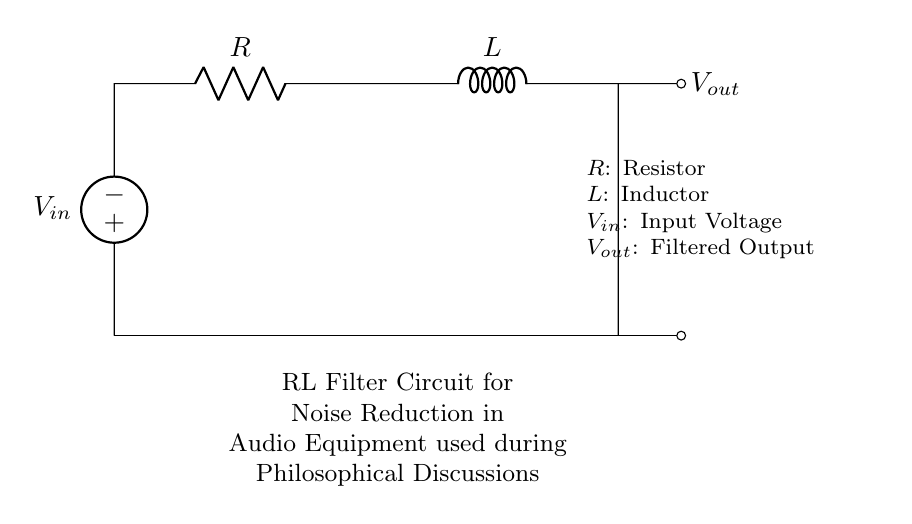What is the type of this circuit? The circuit consists of a resistor and an inductor connected in series, which classifies it as an RL filter circuit.
Answer: RL filter What is the role of the resistor in this circuit? The resistor is primarily used to limit the current flowing through the circuit and helps to set the cutoff frequency along with the inductor.
Answer: Current limiter What is the purpose of the inductor in this RL circuit? The inductor stores energy in a magnetic field when current passes through it and opposes changes in current, thereby filtering out high-frequency noise.
Answer: Noise filter What type of voltage is represented by Vout? Vout represents the filtered output voltage, which is the voltage across the load after the filter has processed the input voltage.
Answer: Filtered output What is the relationship between resistance (R) and inductance (L) in determining the cutoff frequency? The cutoff frequency is determined by the values of resistance and inductance; specifically, it is calculated using the formula f_c equals one over two pi times the square root of L over R.
Answer: Cutoff frequency How does increasing the resistance affect the output voltage? Increasing resistance reduces the current in the circuit, which leads to a lower output voltage across the inductor for a given input voltage, effectively reducing the filtering effect at higher frequencies.
Answer: Lower output voltage 